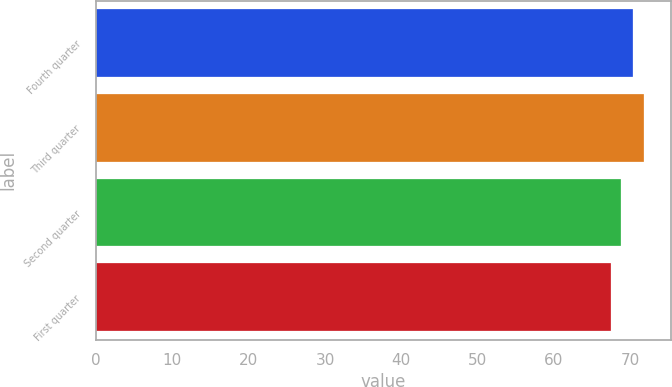Convert chart to OTSL. <chart><loc_0><loc_0><loc_500><loc_500><bar_chart><fcel>Fourth quarter<fcel>Third quarter<fcel>Second quarter<fcel>First quarter<nl><fcel>70.29<fcel>71.77<fcel>68.77<fcel>67.48<nl></chart> 